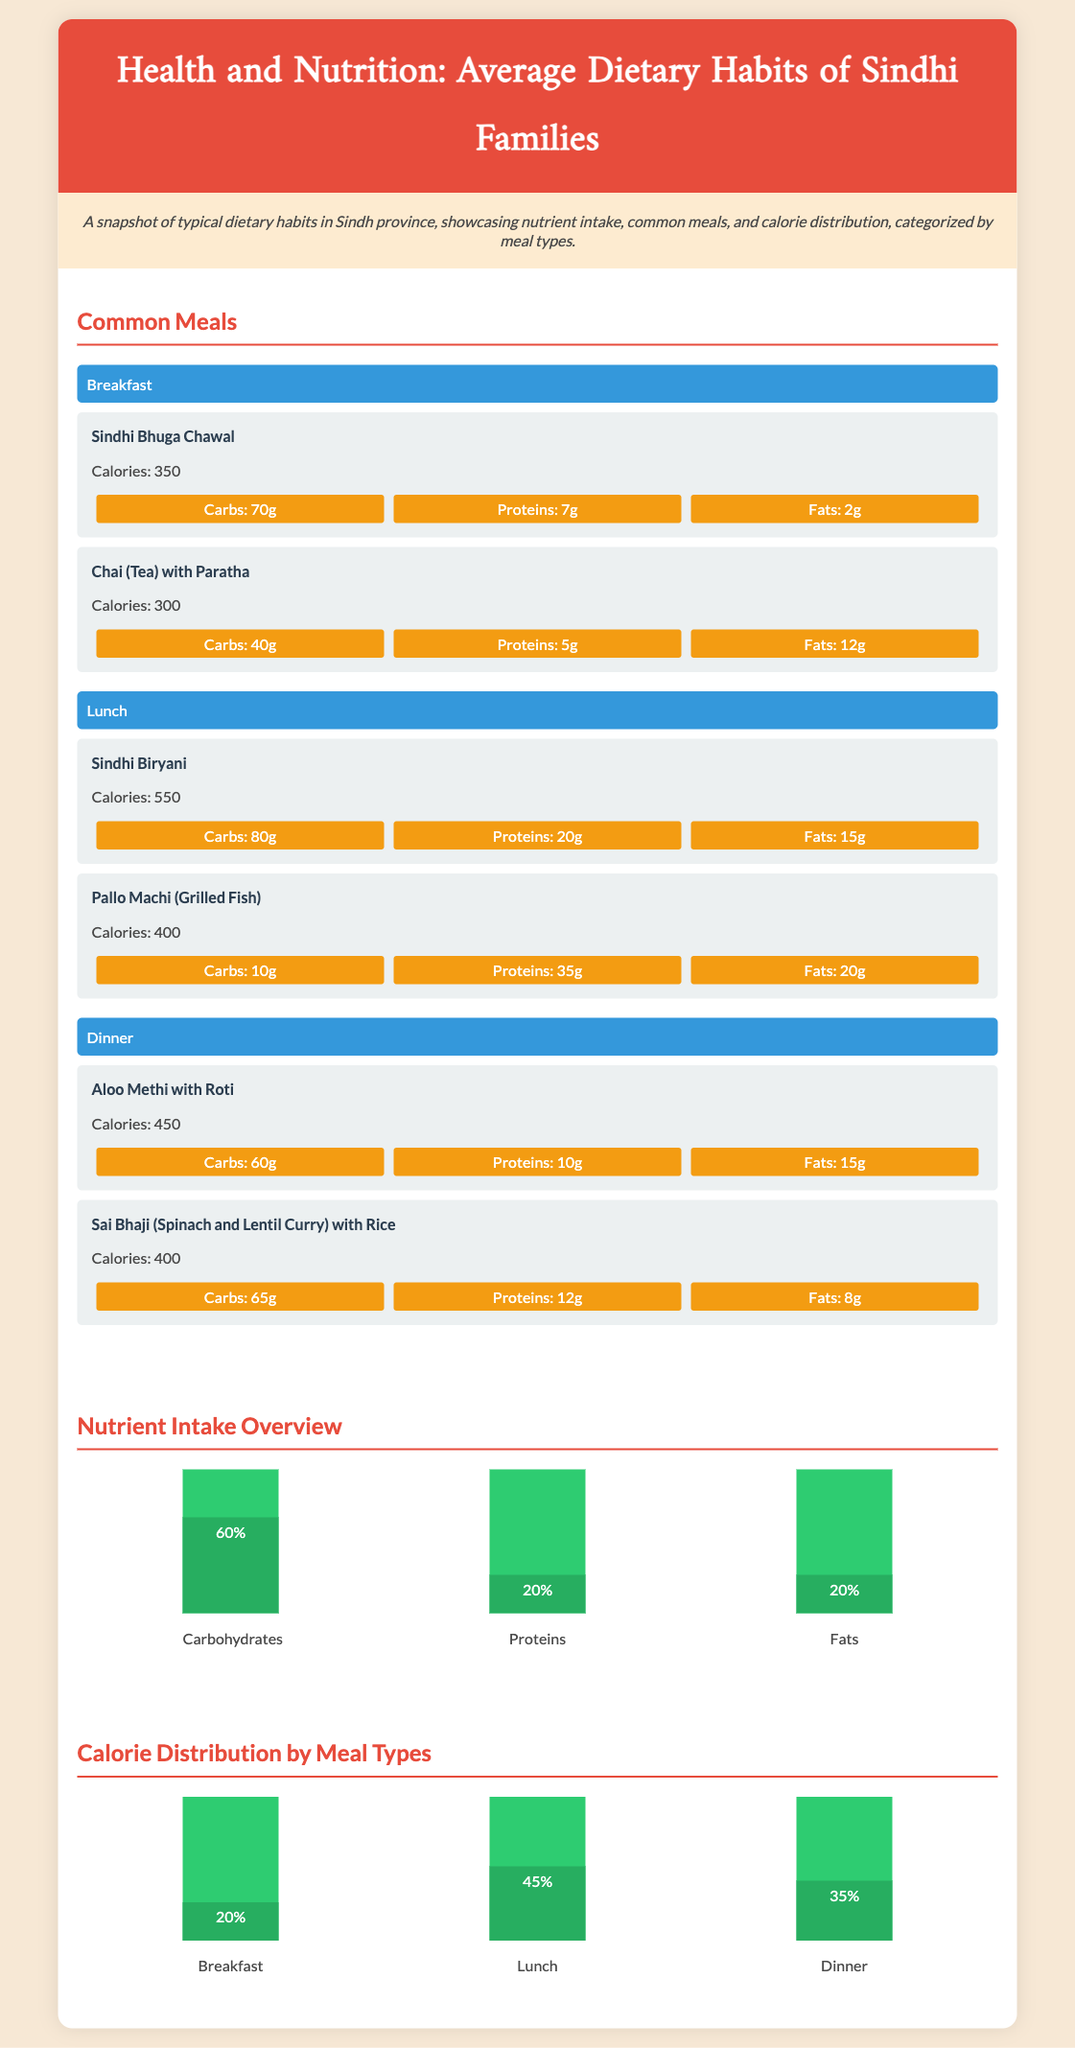What are the two main nutrients in breakfast meals? The two main nutrients found in breakfast meals are typically carbohydrates and proteins, as highlighted in the nutrient distribution for Sindhi breakfast items.
Answer: Carbs and Proteins How many calories does Sindhi Biryani contain? The calorie content for Sindhi Biryani is specified in the document, indicating the amount provided per serving.
Answer: 550 What percentage of total calorie intake does lunch contribute? The document provides a breakdown of calorie distribution by meal types, indicating the portion attributed to lunch specifically.
Answer: 45% Which meal has the highest calorie content? The comparison of calorie content among meals shows that one specific meal out of the three has the most calories.
Answer: Lunch How much protein is in Pallo Machi? The protein content for Pallo Machi is clearly defined in the meal item details.
Answer: 35g What is the calorie distribution percentage for dinner? The infographic states the percentage of total calories attributed to dinner among meal types.
Answer: 35% Name a common breakfast item listed in the infographic. The document lists various meals, specifically noting a popular breakfast dish in the Sindhi diet.
Answer: Sindhi Bhuga Chawal What nutrient makes up 60% of the total intake according to the overview? The nutrient intake overview categorizes the main nutrients, clearly indicating the majority constituent.
Answer: Carbohydrates How many grams of fats are in Aloo Methi with Roti? The document specifies the fat content in the meal item description for Aloo Methi with Roti.
Answer: 15g 